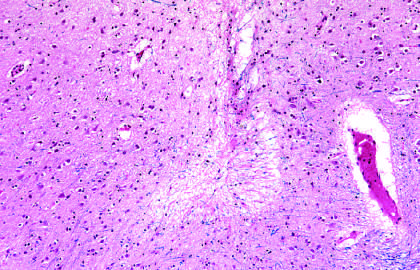what are old intracortical infarcts seen as?
Answer the question using a single word or phrase. Areas of tissue loss and residual gliosis 